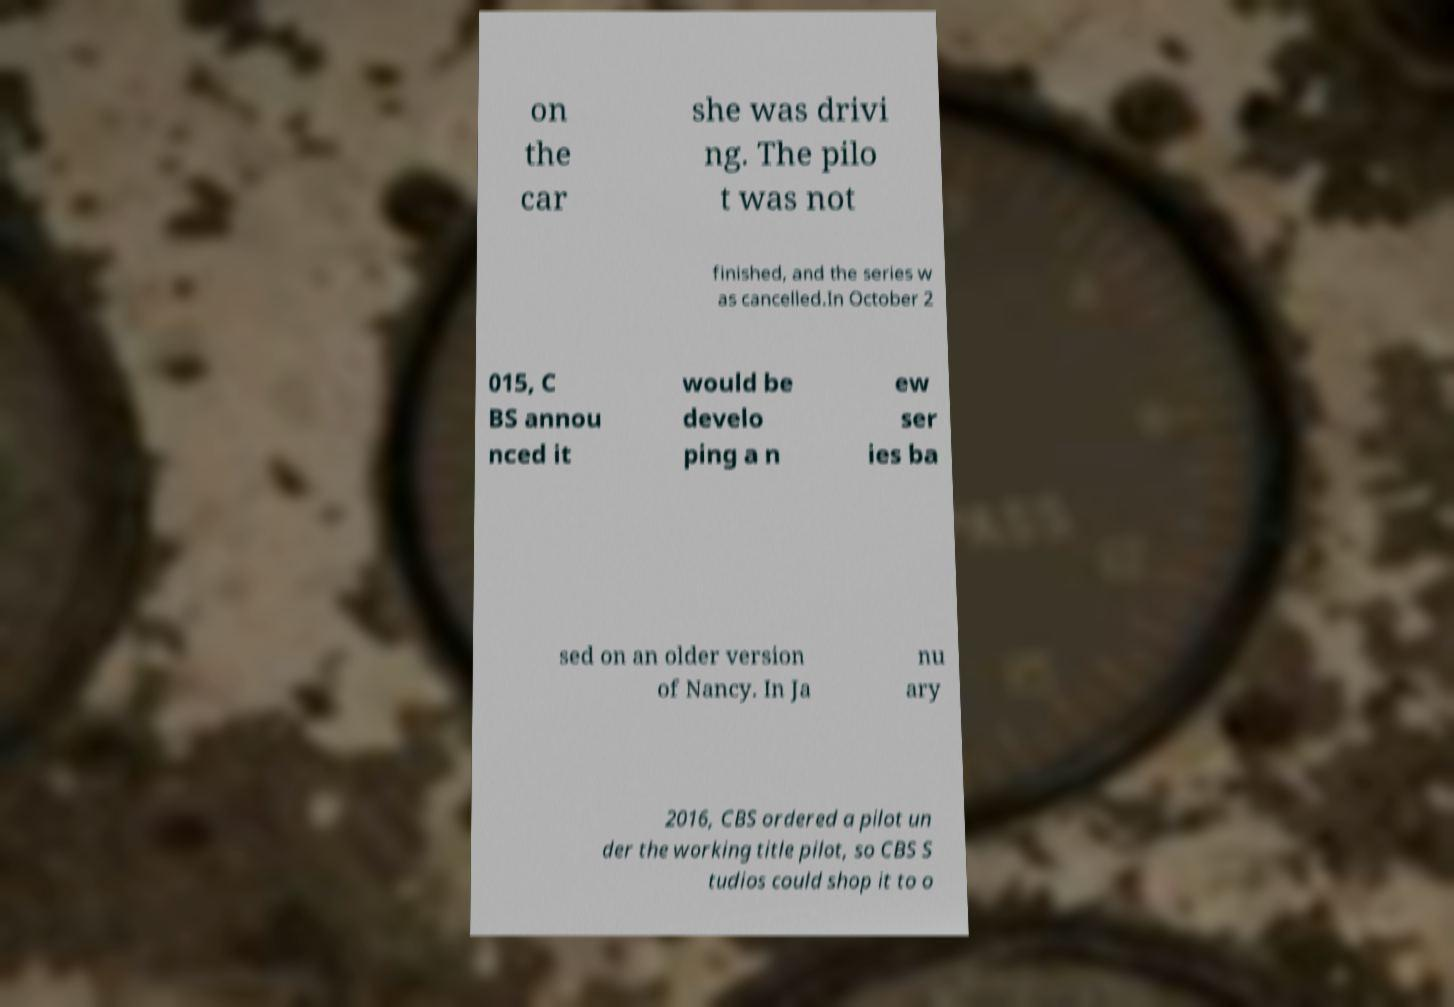There's text embedded in this image that I need extracted. Can you transcribe it verbatim? on the car she was drivi ng. The pilo t was not finished, and the series w as cancelled.In October 2 015, C BS annou nced it would be develo ping a n ew ser ies ba sed on an older version of Nancy. In Ja nu ary 2016, CBS ordered a pilot un der the working title pilot, so CBS S tudios could shop it to o 